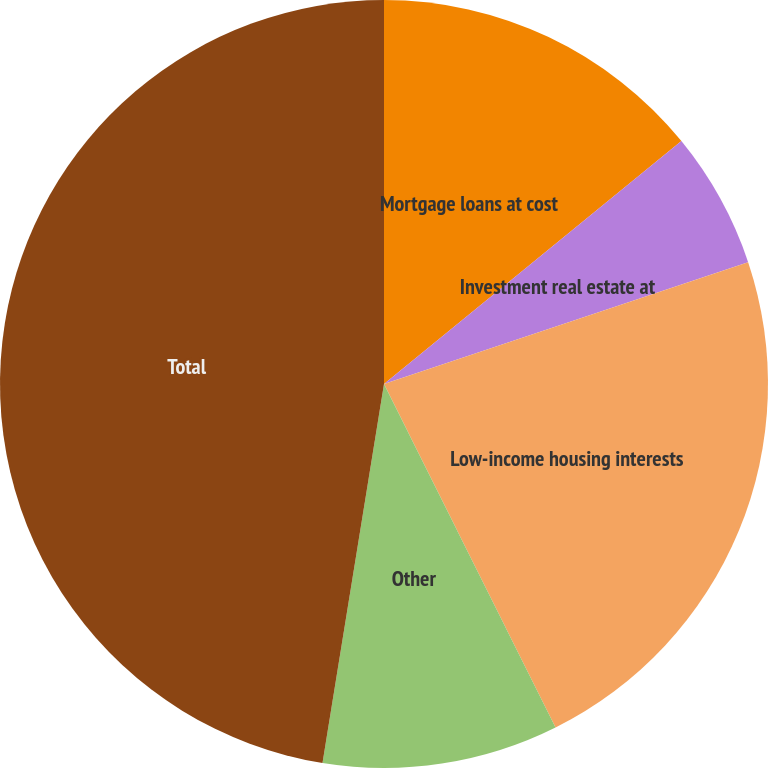Convert chart. <chart><loc_0><loc_0><loc_500><loc_500><pie_chart><fcel>Mortgage loans at cost<fcel>Investment real estate at<fcel>Low-income housing interests<fcel>Other<fcel>Total<nl><fcel>14.1%<fcel>5.76%<fcel>22.77%<fcel>9.93%<fcel>47.44%<nl></chart> 